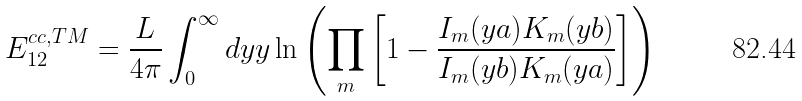Convert formula to latex. <formula><loc_0><loc_0><loc_500><loc_500>E _ { 1 2 } ^ { c c , T M } = \frac { L } { 4 \pi } \int _ { 0 } ^ { \infty } d y y \ln \left ( \prod _ { m } \left [ 1 - \frac { I _ { m } ( y a ) K _ { m } ( y b ) } { I _ { m } ( y b ) K _ { m } ( y a ) } \right ] \right )</formula> 